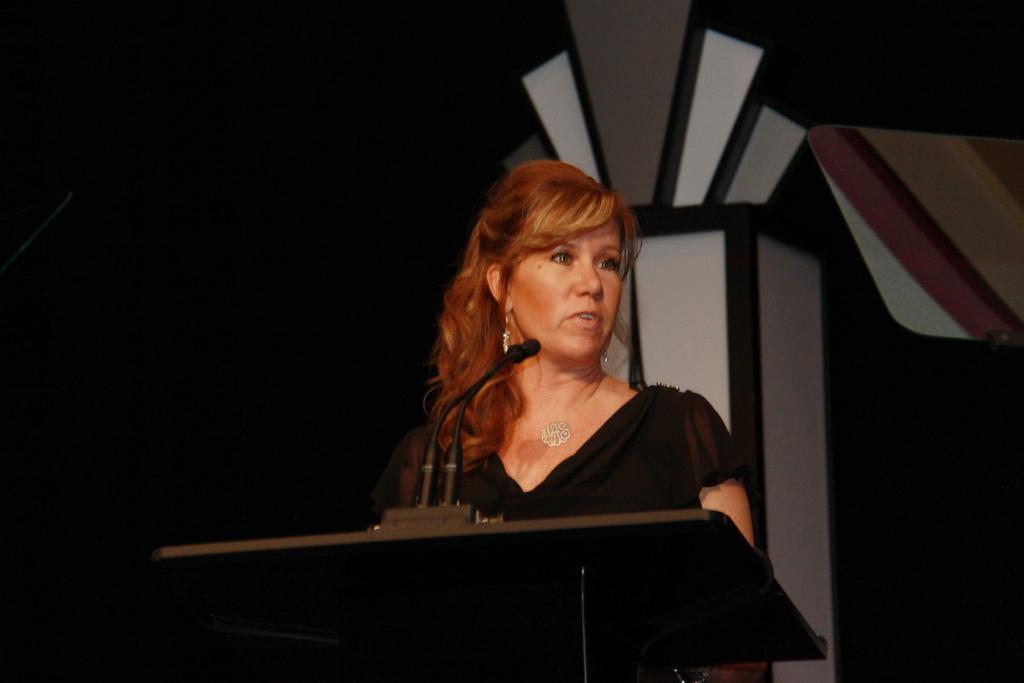How would you summarize this image in a sentence or two? In the center of the picture there is a woman in black dress, in front of a podium and speaking into microphones. In the background there is a pillar. The background is dark. 